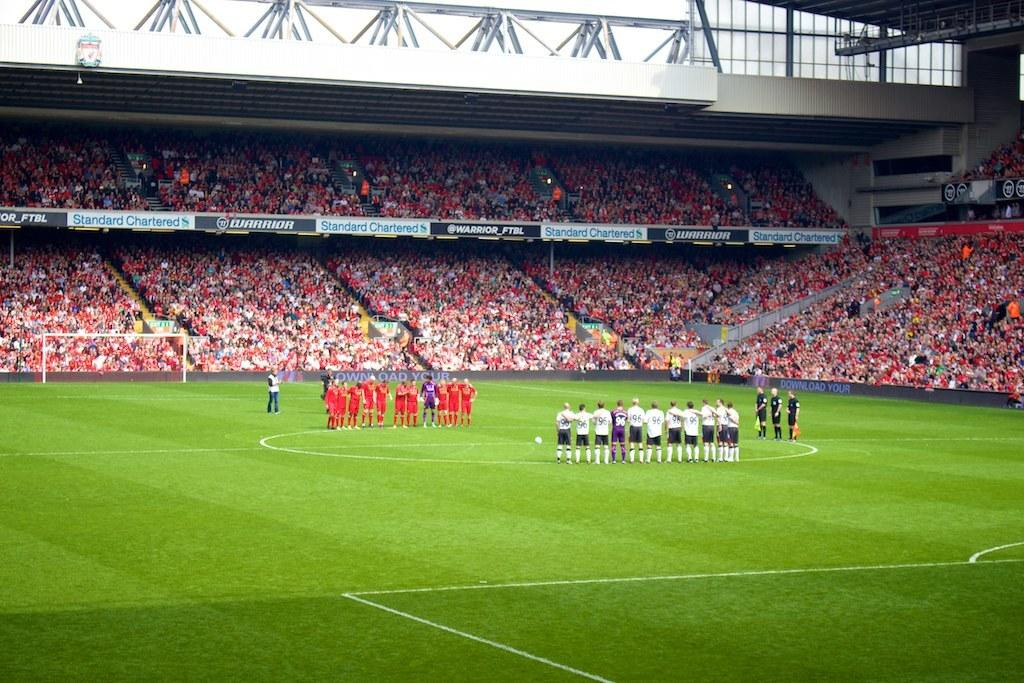<image>
Offer a succinct explanation of the picture presented. a soccer field with a sideline banner that says 'warrior_ftbl' 